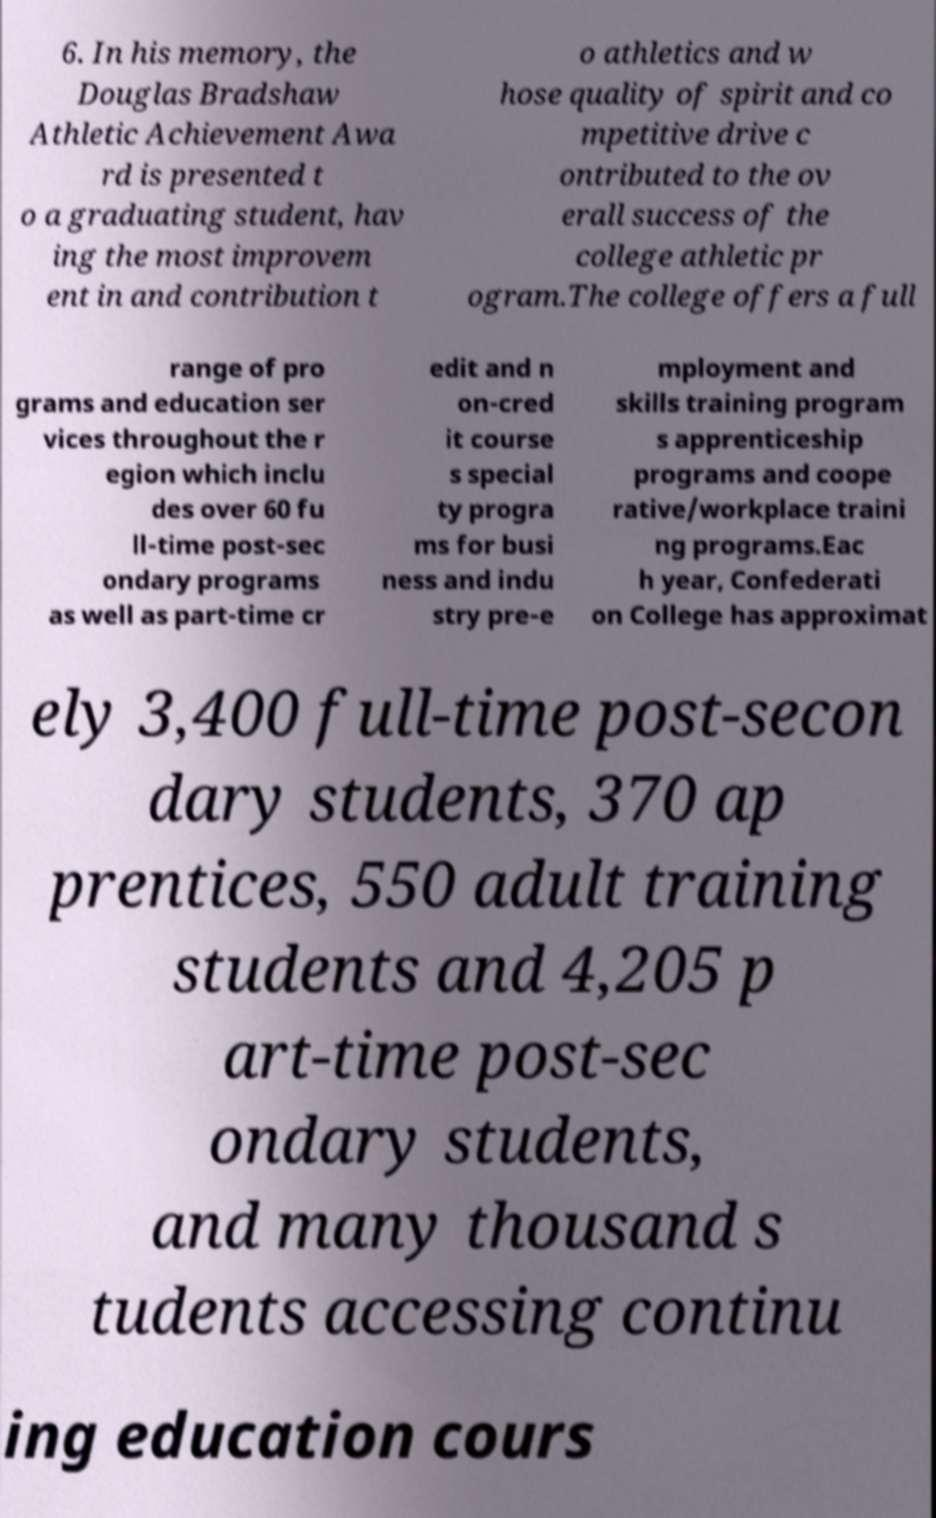Could you assist in decoding the text presented in this image and type it out clearly? 6. In his memory, the Douglas Bradshaw Athletic Achievement Awa rd is presented t o a graduating student, hav ing the most improvem ent in and contribution t o athletics and w hose quality of spirit and co mpetitive drive c ontributed to the ov erall success of the college athletic pr ogram.The college offers a full range of pro grams and education ser vices throughout the r egion which inclu des over 60 fu ll-time post-sec ondary programs as well as part-time cr edit and n on-cred it course s special ty progra ms for busi ness and indu stry pre-e mployment and skills training program s apprenticeship programs and coope rative/workplace traini ng programs.Eac h year, Confederati on College has approximat ely 3,400 full-time post-secon dary students, 370 ap prentices, 550 adult training students and 4,205 p art-time post-sec ondary students, and many thousand s tudents accessing continu ing education cours 